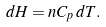Convert formula to latex. <formula><loc_0><loc_0><loc_500><loc_500>d H = n C _ { p } \, d T .</formula> 